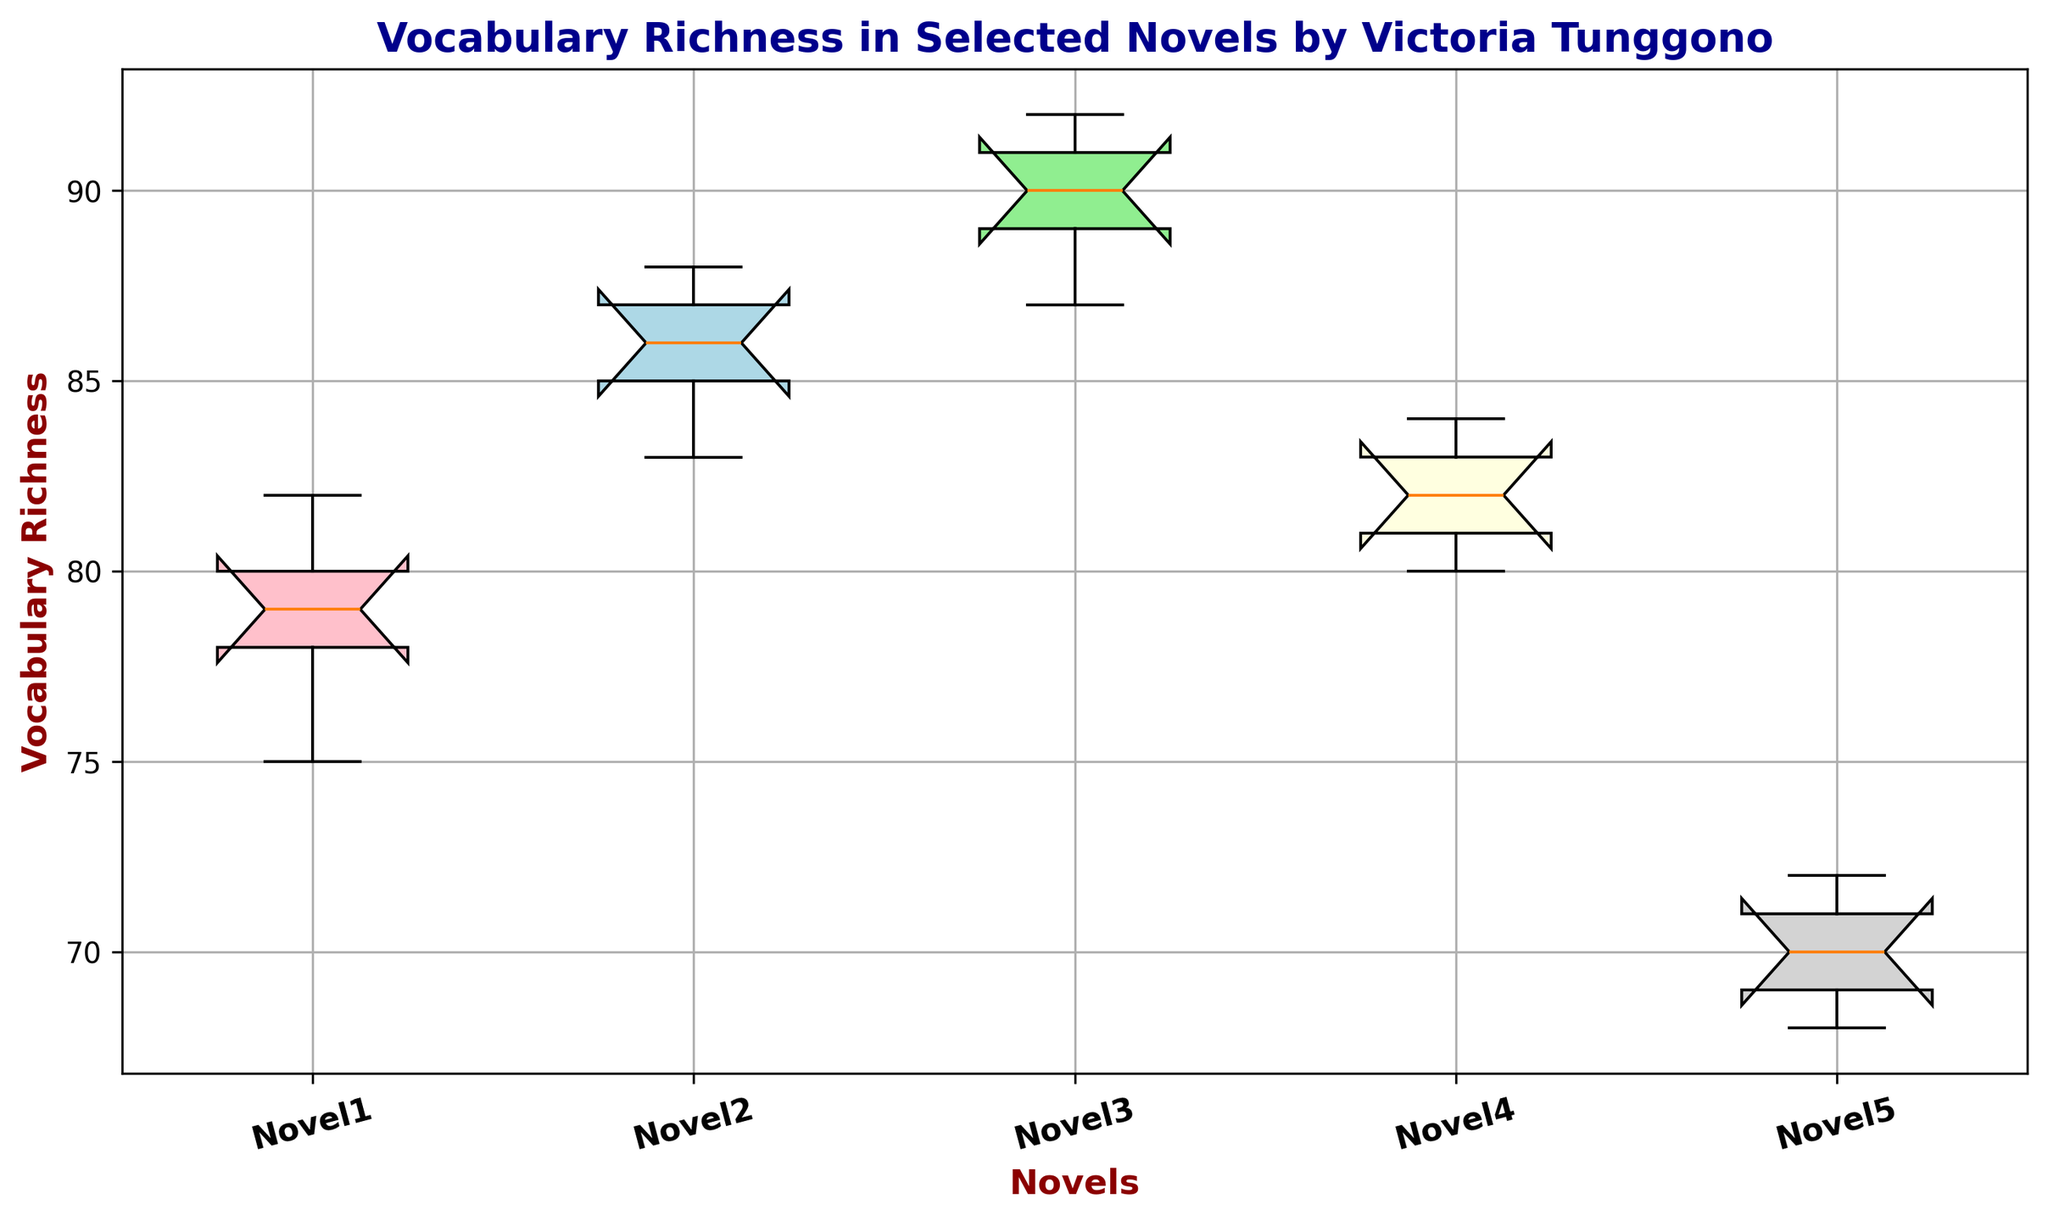What's the range of Vocabulary Richness for Novel3? The range is calculated by subtracting the smallest value from the largest value. For Novel3, the smallest value is 87 and the largest is 92. So, 92 - 87 gives us the range.
Answer: 5 Which novel has the highest median Vocabulary Richness? To determine the highest median, compare the medians of all the novels displayed on the box plot. The novel with the highest median would be the one with the median line at the highest position on the y-axis.
Answer: Novel3 Is the interquartile range (IQR) for Novel5 wider or narrower compared to Novel1? The IQR is calculated by subtracting the first quartile (Q1) from the third quartile (Q3). Assess the relative widths of the boxes for Novel5 and Novel1 on the box plot. If the box for Novel5 appears wider, it has a wider IQR; otherwise, it is narrower.
Answer: Wider How does the median Vocabulary Richness of Novel4 compare to that of Novel1? Medians are indicated by the lines inside the boxes. Compare the position of the median line for Novel4 with that of Novel1.
Answer: Higher Which novels show outliers, if any? Outliers are typically represented as individual points outside of the whiskers of the box plot. Identify the novels with such points.
Answer: None What is the median Vocabulary Richness across all novels? To find the overall median, first compile all the data points across all novels and then find the middle value of this combined set. If there are an even number of data points, average the two middle values.
Answer: 82 For which novel is the spread of Vocabulary Richness values the smallest? The spread of values is indicated by the length of the whiskers. Identify the novel with the shortest whiskers on the box plot.
Answer: Novel4 Is there a novel where all the Vocabulary Richness values are above 85? Check if the lowest value (the bottom whisker) for any novel is above 85.
Answer: Novel3 